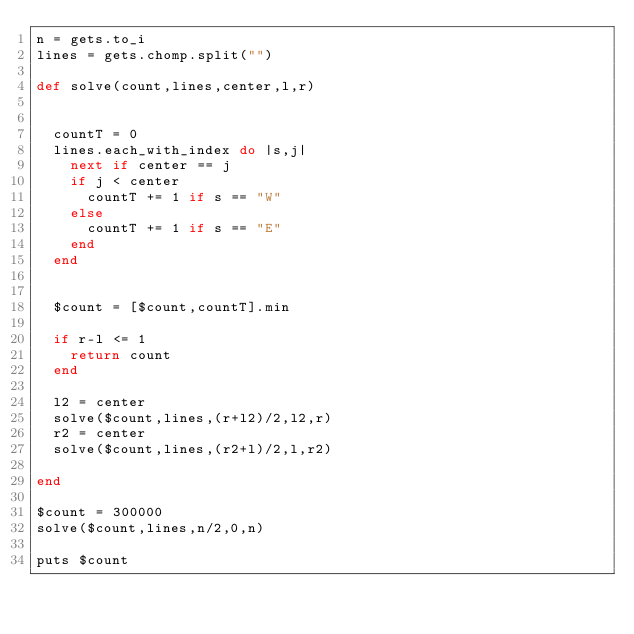Convert code to text. <code><loc_0><loc_0><loc_500><loc_500><_Ruby_>n = gets.to_i
lines = gets.chomp.split("")

def solve(count,lines,center,l,r)


  countT = 0
  lines.each_with_index do |s,j|
    next if center == j
    if j < center
      countT += 1 if s == "W"
    else
      countT += 1 if s == "E"
    end
  end


  $count = [$count,countT].min

  if r-l <= 1
    return count
  end

  l2 = center
  solve($count,lines,(r+l2)/2,l2,r)
  r2 = center
  solve($count,lines,(r2+l)/2,l,r2)

end

$count = 300000
solve($count,lines,n/2,0,n)

puts $count</code> 